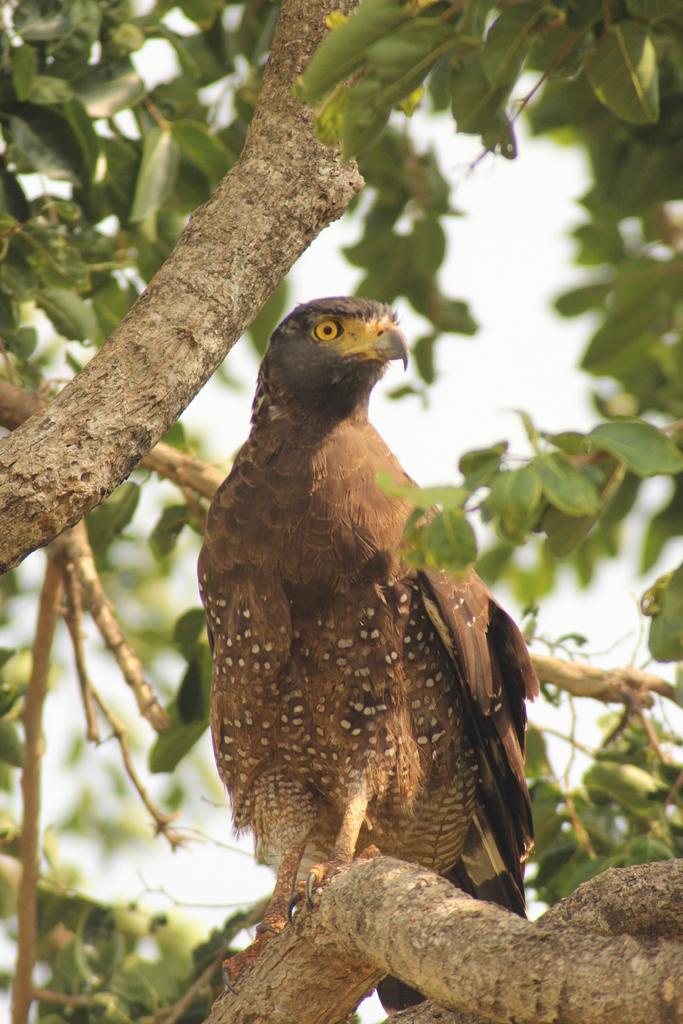Could you give a brief overview of what you see in this image? In this image we can see a bird on a branch and behind it there are branches and leaves. 